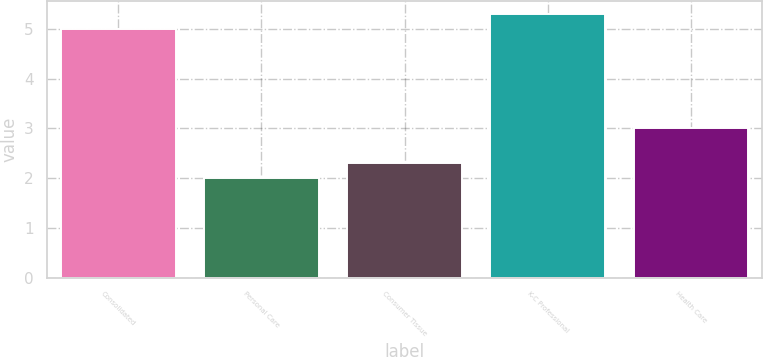<chart> <loc_0><loc_0><loc_500><loc_500><bar_chart><fcel>Consolidated<fcel>Personal Care<fcel>Consumer Tissue<fcel>K-C Professional<fcel>Health Care<nl><fcel>5<fcel>2<fcel>2.3<fcel>5.3<fcel>3<nl></chart> 